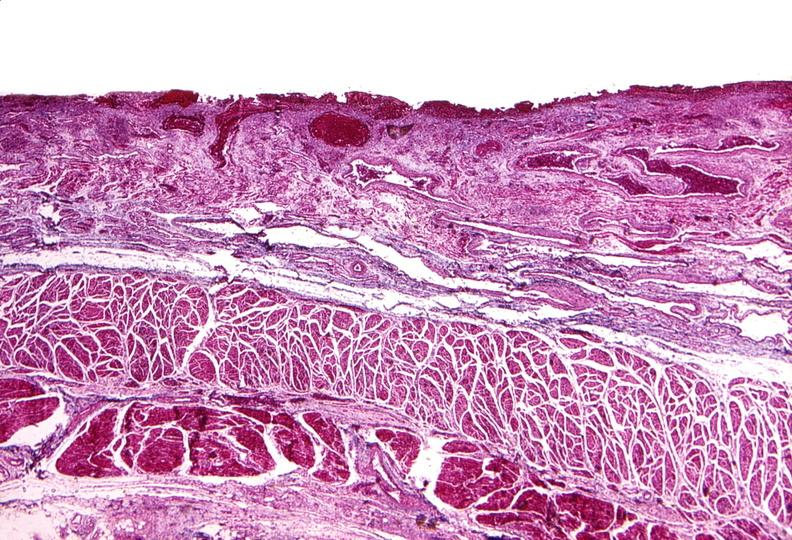does this image show esophagus, varices?
Answer the question using a single word or phrase. Yes 